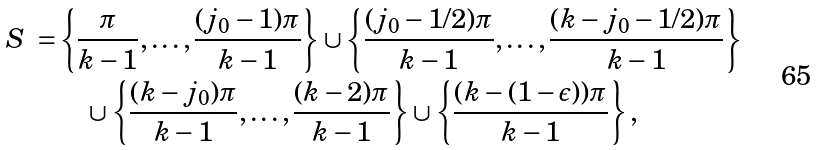<formula> <loc_0><loc_0><loc_500><loc_500>\emph { S } = & \left \{ \frac { \pi } { k - 1 } , \dots , \frac { ( j _ { 0 } - 1 ) \pi } { k - 1 } \right \} \cup \left \{ \frac { ( j _ { 0 } - 1 / 2 ) \pi } { k - 1 } , \dots , \frac { ( k - j _ { 0 } - 1 / 2 ) \pi } { k - 1 } \right \} \\ & \quad \cup \left \{ \frac { ( k - j _ { 0 } ) \pi } { k - 1 } , \dots , \frac { ( k - 2 ) \pi } { k - 1 } \right \} \cup \left \{ \frac { ( k - ( 1 - \epsilon ) ) \pi } { k - 1 } \right \} ,</formula> 